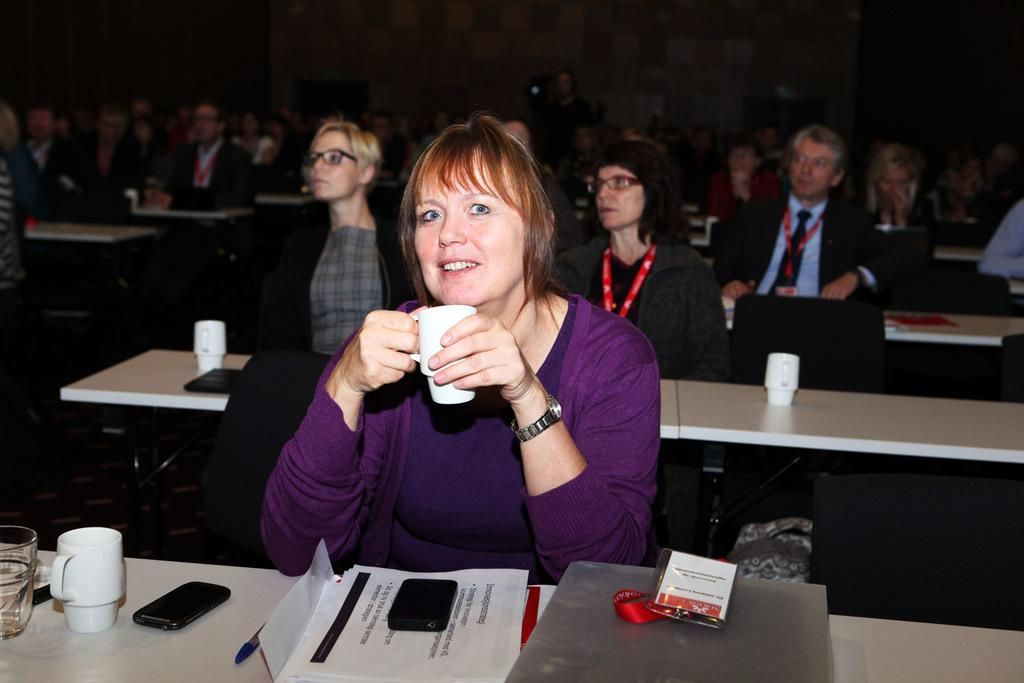What are the people in the image doing? The people in the image are sitting in a group. What objects are in front of the people? There are tables in front of the people. What items can be seen on the table? There is a glass, a cup, a mobile phone, a paper, a badge, and files on the table. What type of kite is being used for the operation in the image? There is no kite or operation present in the image. What type of business is being conducted in the image? The image does not depict any business activities; it shows people sitting around tables with various objects. 